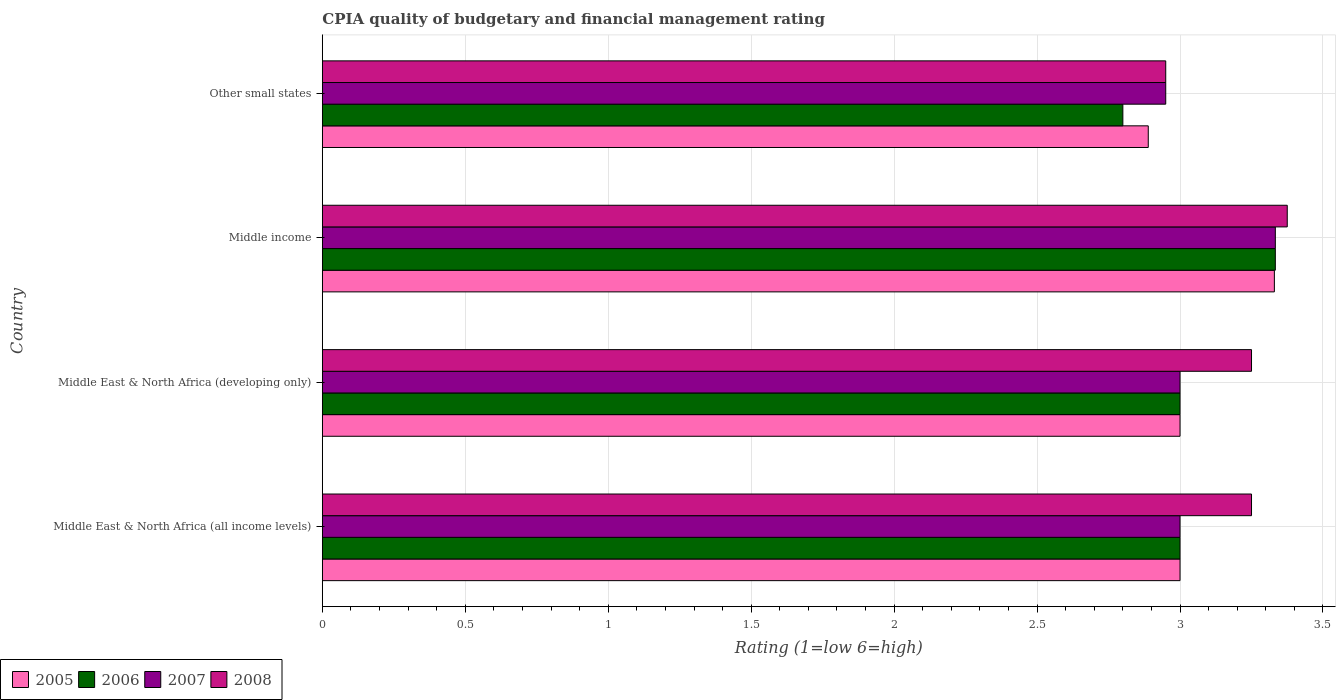How many different coloured bars are there?
Offer a terse response. 4. Are the number of bars on each tick of the Y-axis equal?
Your response must be concise. Yes. How many bars are there on the 3rd tick from the bottom?
Ensure brevity in your answer.  4. What is the label of the 4th group of bars from the top?
Offer a very short reply. Middle East & North Africa (all income levels). Across all countries, what is the maximum CPIA rating in 2007?
Your response must be concise. 3.33. Across all countries, what is the minimum CPIA rating in 2006?
Offer a terse response. 2.8. In which country was the CPIA rating in 2006 minimum?
Keep it short and to the point. Other small states. What is the total CPIA rating in 2007 in the graph?
Your response must be concise. 12.28. What is the difference between the CPIA rating in 2008 in Middle income and that in Other small states?
Make the answer very short. 0.42. What is the difference between the CPIA rating in 2006 in Middle income and the CPIA rating in 2005 in Middle East & North Africa (developing only)?
Ensure brevity in your answer.  0.33. What is the average CPIA rating in 2005 per country?
Ensure brevity in your answer.  3.05. What is the difference between the CPIA rating in 2006 and CPIA rating in 2005 in Other small states?
Keep it short and to the point. -0.09. What is the ratio of the CPIA rating in 2005 in Middle East & North Africa (all income levels) to that in Other small states?
Provide a succinct answer. 1.04. Is the CPIA rating in 2006 in Middle income less than that in Other small states?
Offer a terse response. No. What is the difference between the highest and the second highest CPIA rating in 2008?
Offer a terse response. 0.12. What is the difference between the highest and the lowest CPIA rating in 2005?
Make the answer very short. 0.44. Is the sum of the CPIA rating in 2007 in Middle East & North Africa (all income levels) and Middle income greater than the maximum CPIA rating in 2005 across all countries?
Provide a short and direct response. Yes. Is it the case that in every country, the sum of the CPIA rating in 2008 and CPIA rating in 2006 is greater than the sum of CPIA rating in 2007 and CPIA rating in 2005?
Make the answer very short. No. How many bars are there?
Ensure brevity in your answer.  16. Are all the bars in the graph horizontal?
Provide a short and direct response. Yes. Where does the legend appear in the graph?
Offer a terse response. Bottom left. What is the title of the graph?
Make the answer very short. CPIA quality of budgetary and financial management rating. Does "1964" appear as one of the legend labels in the graph?
Provide a succinct answer. No. What is the label or title of the X-axis?
Provide a succinct answer. Rating (1=low 6=high). What is the Rating (1=low 6=high) in 2005 in Middle East & North Africa (all income levels)?
Offer a very short reply. 3. What is the Rating (1=low 6=high) of 2007 in Middle East & North Africa (all income levels)?
Keep it short and to the point. 3. What is the Rating (1=low 6=high) of 2008 in Middle East & North Africa (all income levels)?
Offer a very short reply. 3.25. What is the Rating (1=low 6=high) of 2007 in Middle East & North Africa (developing only)?
Ensure brevity in your answer.  3. What is the Rating (1=low 6=high) in 2005 in Middle income?
Give a very brief answer. 3.33. What is the Rating (1=low 6=high) in 2006 in Middle income?
Offer a very short reply. 3.33. What is the Rating (1=low 6=high) in 2007 in Middle income?
Offer a very short reply. 3.33. What is the Rating (1=low 6=high) in 2008 in Middle income?
Your response must be concise. 3.38. What is the Rating (1=low 6=high) in 2005 in Other small states?
Your answer should be compact. 2.89. What is the Rating (1=low 6=high) in 2007 in Other small states?
Give a very brief answer. 2.95. What is the Rating (1=low 6=high) in 2008 in Other small states?
Give a very brief answer. 2.95. Across all countries, what is the maximum Rating (1=low 6=high) in 2005?
Provide a succinct answer. 3.33. Across all countries, what is the maximum Rating (1=low 6=high) of 2006?
Your response must be concise. 3.33. Across all countries, what is the maximum Rating (1=low 6=high) in 2007?
Provide a succinct answer. 3.33. Across all countries, what is the maximum Rating (1=low 6=high) of 2008?
Provide a succinct answer. 3.38. Across all countries, what is the minimum Rating (1=low 6=high) of 2005?
Your answer should be compact. 2.89. Across all countries, what is the minimum Rating (1=low 6=high) in 2007?
Your response must be concise. 2.95. Across all countries, what is the minimum Rating (1=low 6=high) in 2008?
Your answer should be compact. 2.95. What is the total Rating (1=low 6=high) of 2005 in the graph?
Offer a terse response. 12.22. What is the total Rating (1=low 6=high) in 2006 in the graph?
Provide a succinct answer. 12.13. What is the total Rating (1=low 6=high) of 2007 in the graph?
Keep it short and to the point. 12.28. What is the total Rating (1=low 6=high) of 2008 in the graph?
Offer a terse response. 12.82. What is the difference between the Rating (1=low 6=high) in 2005 in Middle East & North Africa (all income levels) and that in Middle East & North Africa (developing only)?
Offer a very short reply. 0. What is the difference between the Rating (1=low 6=high) of 2005 in Middle East & North Africa (all income levels) and that in Middle income?
Your response must be concise. -0.33. What is the difference between the Rating (1=low 6=high) of 2006 in Middle East & North Africa (all income levels) and that in Middle income?
Make the answer very short. -0.33. What is the difference between the Rating (1=low 6=high) in 2008 in Middle East & North Africa (all income levels) and that in Middle income?
Give a very brief answer. -0.12. What is the difference between the Rating (1=low 6=high) in 2005 in Middle East & North Africa (all income levels) and that in Other small states?
Make the answer very short. 0.11. What is the difference between the Rating (1=low 6=high) in 2005 in Middle East & North Africa (developing only) and that in Middle income?
Your answer should be compact. -0.33. What is the difference between the Rating (1=low 6=high) in 2008 in Middle East & North Africa (developing only) and that in Middle income?
Your response must be concise. -0.12. What is the difference between the Rating (1=low 6=high) of 2007 in Middle East & North Africa (developing only) and that in Other small states?
Offer a terse response. 0.05. What is the difference between the Rating (1=low 6=high) in 2005 in Middle income and that in Other small states?
Provide a succinct answer. 0.44. What is the difference between the Rating (1=low 6=high) of 2006 in Middle income and that in Other small states?
Your answer should be compact. 0.53. What is the difference between the Rating (1=low 6=high) of 2007 in Middle income and that in Other small states?
Provide a succinct answer. 0.38. What is the difference between the Rating (1=low 6=high) of 2008 in Middle income and that in Other small states?
Make the answer very short. 0.42. What is the difference between the Rating (1=low 6=high) of 2005 in Middle East & North Africa (all income levels) and the Rating (1=low 6=high) of 2008 in Middle income?
Provide a short and direct response. -0.38. What is the difference between the Rating (1=low 6=high) in 2006 in Middle East & North Africa (all income levels) and the Rating (1=low 6=high) in 2008 in Middle income?
Your response must be concise. -0.38. What is the difference between the Rating (1=low 6=high) in 2007 in Middle East & North Africa (all income levels) and the Rating (1=low 6=high) in 2008 in Middle income?
Your answer should be very brief. -0.38. What is the difference between the Rating (1=low 6=high) of 2005 in Middle East & North Africa (all income levels) and the Rating (1=low 6=high) of 2006 in Other small states?
Your response must be concise. 0.2. What is the difference between the Rating (1=low 6=high) in 2005 in Middle East & North Africa (all income levels) and the Rating (1=low 6=high) in 2007 in Other small states?
Give a very brief answer. 0.05. What is the difference between the Rating (1=low 6=high) in 2005 in Middle East & North Africa (all income levels) and the Rating (1=low 6=high) in 2008 in Other small states?
Ensure brevity in your answer.  0.05. What is the difference between the Rating (1=low 6=high) of 2006 in Middle East & North Africa (all income levels) and the Rating (1=low 6=high) of 2007 in Other small states?
Offer a very short reply. 0.05. What is the difference between the Rating (1=low 6=high) of 2006 in Middle East & North Africa (all income levels) and the Rating (1=low 6=high) of 2008 in Other small states?
Your answer should be very brief. 0.05. What is the difference between the Rating (1=low 6=high) in 2005 in Middle East & North Africa (developing only) and the Rating (1=low 6=high) in 2008 in Middle income?
Keep it short and to the point. -0.38. What is the difference between the Rating (1=low 6=high) of 2006 in Middle East & North Africa (developing only) and the Rating (1=low 6=high) of 2007 in Middle income?
Keep it short and to the point. -0.33. What is the difference between the Rating (1=low 6=high) of 2006 in Middle East & North Africa (developing only) and the Rating (1=low 6=high) of 2008 in Middle income?
Ensure brevity in your answer.  -0.38. What is the difference between the Rating (1=low 6=high) in 2007 in Middle East & North Africa (developing only) and the Rating (1=low 6=high) in 2008 in Middle income?
Provide a succinct answer. -0.38. What is the difference between the Rating (1=low 6=high) of 2005 in Middle income and the Rating (1=low 6=high) of 2006 in Other small states?
Your answer should be compact. 0.53. What is the difference between the Rating (1=low 6=high) in 2005 in Middle income and the Rating (1=low 6=high) in 2007 in Other small states?
Offer a terse response. 0.38. What is the difference between the Rating (1=low 6=high) in 2005 in Middle income and the Rating (1=low 6=high) in 2008 in Other small states?
Your answer should be compact. 0.38. What is the difference between the Rating (1=low 6=high) of 2006 in Middle income and the Rating (1=low 6=high) of 2007 in Other small states?
Ensure brevity in your answer.  0.38. What is the difference between the Rating (1=low 6=high) in 2006 in Middle income and the Rating (1=low 6=high) in 2008 in Other small states?
Provide a succinct answer. 0.38. What is the difference between the Rating (1=low 6=high) in 2007 in Middle income and the Rating (1=low 6=high) in 2008 in Other small states?
Your response must be concise. 0.38. What is the average Rating (1=low 6=high) of 2005 per country?
Offer a terse response. 3.05. What is the average Rating (1=low 6=high) of 2006 per country?
Offer a terse response. 3.03. What is the average Rating (1=low 6=high) of 2007 per country?
Ensure brevity in your answer.  3.07. What is the average Rating (1=low 6=high) of 2008 per country?
Make the answer very short. 3.21. What is the difference between the Rating (1=low 6=high) in 2005 and Rating (1=low 6=high) in 2006 in Middle East & North Africa (all income levels)?
Make the answer very short. 0. What is the difference between the Rating (1=low 6=high) of 2005 and Rating (1=low 6=high) of 2007 in Middle East & North Africa (all income levels)?
Provide a short and direct response. 0. What is the difference between the Rating (1=low 6=high) in 2005 and Rating (1=low 6=high) in 2008 in Middle East & North Africa (all income levels)?
Give a very brief answer. -0.25. What is the difference between the Rating (1=low 6=high) in 2006 and Rating (1=low 6=high) in 2007 in Middle East & North Africa (all income levels)?
Ensure brevity in your answer.  0. What is the difference between the Rating (1=low 6=high) of 2006 and Rating (1=low 6=high) of 2008 in Middle East & North Africa (all income levels)?
Your answer should be very brief. -0.25. What is the difference between the Rating (1=low 6=high) of 2005 and Rating (1=low 6=high) of 2008 in Middle East & North Africa (developing only)?
Offer a terse response. -0.25. What is the difference between the Rating (1=low 6=high) in 2006 and Rating (1=low 6=high) in 2007 in Middle East & North Africa (developing only)?
Offer a terse response. 0. What is the difference between the Rating (1=low 6=high) in 2006 and Rating (1=low 6=high) in 2008 in Middle East & North Africa (developing only)?
Ensure brevity in your answer.  -0.25. What is the difference between the Rating (1=low 6=high) in 2005 and Rating (1=low 6=high) in 2006 in Middle income?
Offer a very short reply. -0. What is the difference between the Rating (1=low 6=high) in 2005 and Rating (1=low 6=high) in 2007 in Middle income?
Provide a short and direct response. -0. What is the difference between the Rating (1=low 6=high) in 2005 and Rating (1=low 6=high) in 2008 in Middle income?
Provide a succinct answer. -0.04. What is the difference between the Rating (1=low 6=high) in 2006 and Rating (1=low 6=high) in 2007 in Middle income?
Your answer should be very brief. 0. What is the difference between the Rating (1=low 6=high) in 2006 and Rating (1=low 6=high) in 2008 in Middle income?
Offer a terse response. -0.04. What is the difference between the Rating (1=low 6=high) in 2007 and Rating (1=low 6=high) in 2008 in Middle income?
Offer a very short reply. -0.04. What is the difference between the Rating (1=low 6=high) in 2005 and Rating (1=low 6=high) in 2006 in Other small states?
Your answer should be compact. 0.09. What is the difference between the Rating (1=low 6=high) in 2005 and Rating (1=low 6=high) in 2007 in Other small states?
Your response must be concise. -0.06. What is the difference between the Rating (1=low 6=high) in 2005 and Rating (1=low 6=high) in 2008 in Other small states?
Ensure brevity in your answer.  -0.06. What is the difference between the Rating (1=low 6=high) of 2006 and Rating (1=low 6=high) of 2008 in Other small states?
Make the answer very short. -0.15. What is the ratio of the Rating (1=low 6=high) in 2006 in Middle East & North Africa (all income levels) to that in Middle East & North Africa (developing only)?
Your answer should be compact. 1. What is the ratio of the Rating (1=low 6=high) of 2005 in Middle East & North Africa (all income levels) to that in Middle income?
Ensure brevity in your answer.  0.9. What is the ratio of the Rating (1=low 6=high) in 2006 in Middle East & North Africa (all income levels) to that in Other small states?
Your response must be concise. 1.07. What is the ratio of the Rating (1=low 6=high) in 2007 in Middle East & North Africa (all income levels) to that in Other small states?
Offer a terse response. 1.02. What is the ratio of the Rating (1=low 6=high) of 2008 in Middle East & North Africa (all income levels) to that in Other small states?
Give a very brief answer. 1.1. What is the ratio of the Rating (1=low 6=high) of 2005 in Middle East & North Africa (developing only) to that in Middle income?
Offer a terse response. 0.9. What is the ratio of the Rating (1=low 6=high) in 2007 in Middle East & North Africa (developing only) to that in Middle income?
Offer a terse response. 0.9. What is the ratio of the Rating (1=low 6=high) of 2008 in Middle East & North Africa (developing only) to that in Middle income?
Offer a terse response. 0.96. What is the ratio of the Rating (1=low 6=high) in 2005 in Middle East & North Africa (developing only) to that in Other small states?
Your answer should be very brief. 1.04. What is the ratio of the Rating (1=low 6=high) in 2006 in Middle East & North Africa (developing only) to that in Other small states?
Your answer should be very brief. 1.07. What is the ratio of the Rating (1=low 6=high) of 2007 in Middle East & North Africa (developing only) to that in Other small states?
Your response must be concise. 1.02. What is the ratio of the Rating (1=low 6=high) in 2008 in Middle East & North Africa (developing only) to that in Other small states?
Keep it short and to the point. 1.1. What is the ratio of the Rating (1=low 6=high) of 2005 in Middle income to that in Other small states?
Ensure brevity in your answer.  1.15. What is the ratio of the Rating (1=low 6=high) in 2006 in Middle income to that in Other small states?
Provide a succinct answer. 1.19. What is the ratio of the Rating (1=low 6=high) of 2007 in Middle income to that in Other small states?
Give a very brief answer. 1.13. What is the ratio of the Rating (1=low 6=high) in 2008 in Middle income to that in Other small states?
Make the answer very short. 1.14. What is the difference between the highest and the second highest Rating (1=low 6=high) of 2005?
Your answer should be compact. 0.33. What is the difference between the highest and the second highest Rating (1=low 6=high) in 2006?
Offer a very short reply. 0.33. What is the difference between the highest and the second highest Rating (1=low 6=high) of 2008?
Your answer should be compact. 0.12. What is the difference between the highest and the lowest Rating (1=low 6=high) of 2005?
Keep it short and to the point. 0.44. What is the difference between the highest and the lowest Rating (1=low 6=high) in 2006?
Your answer should be compact. 0.53. What is the difference between the highest and the lowest Rating (1=low 6=high) in 2007?
Your response must be concise. 0.38. What is the difference between the highest and the lowest Rating (1=low 6=high) in 2008?
Offer a very short reply. 0.42. 